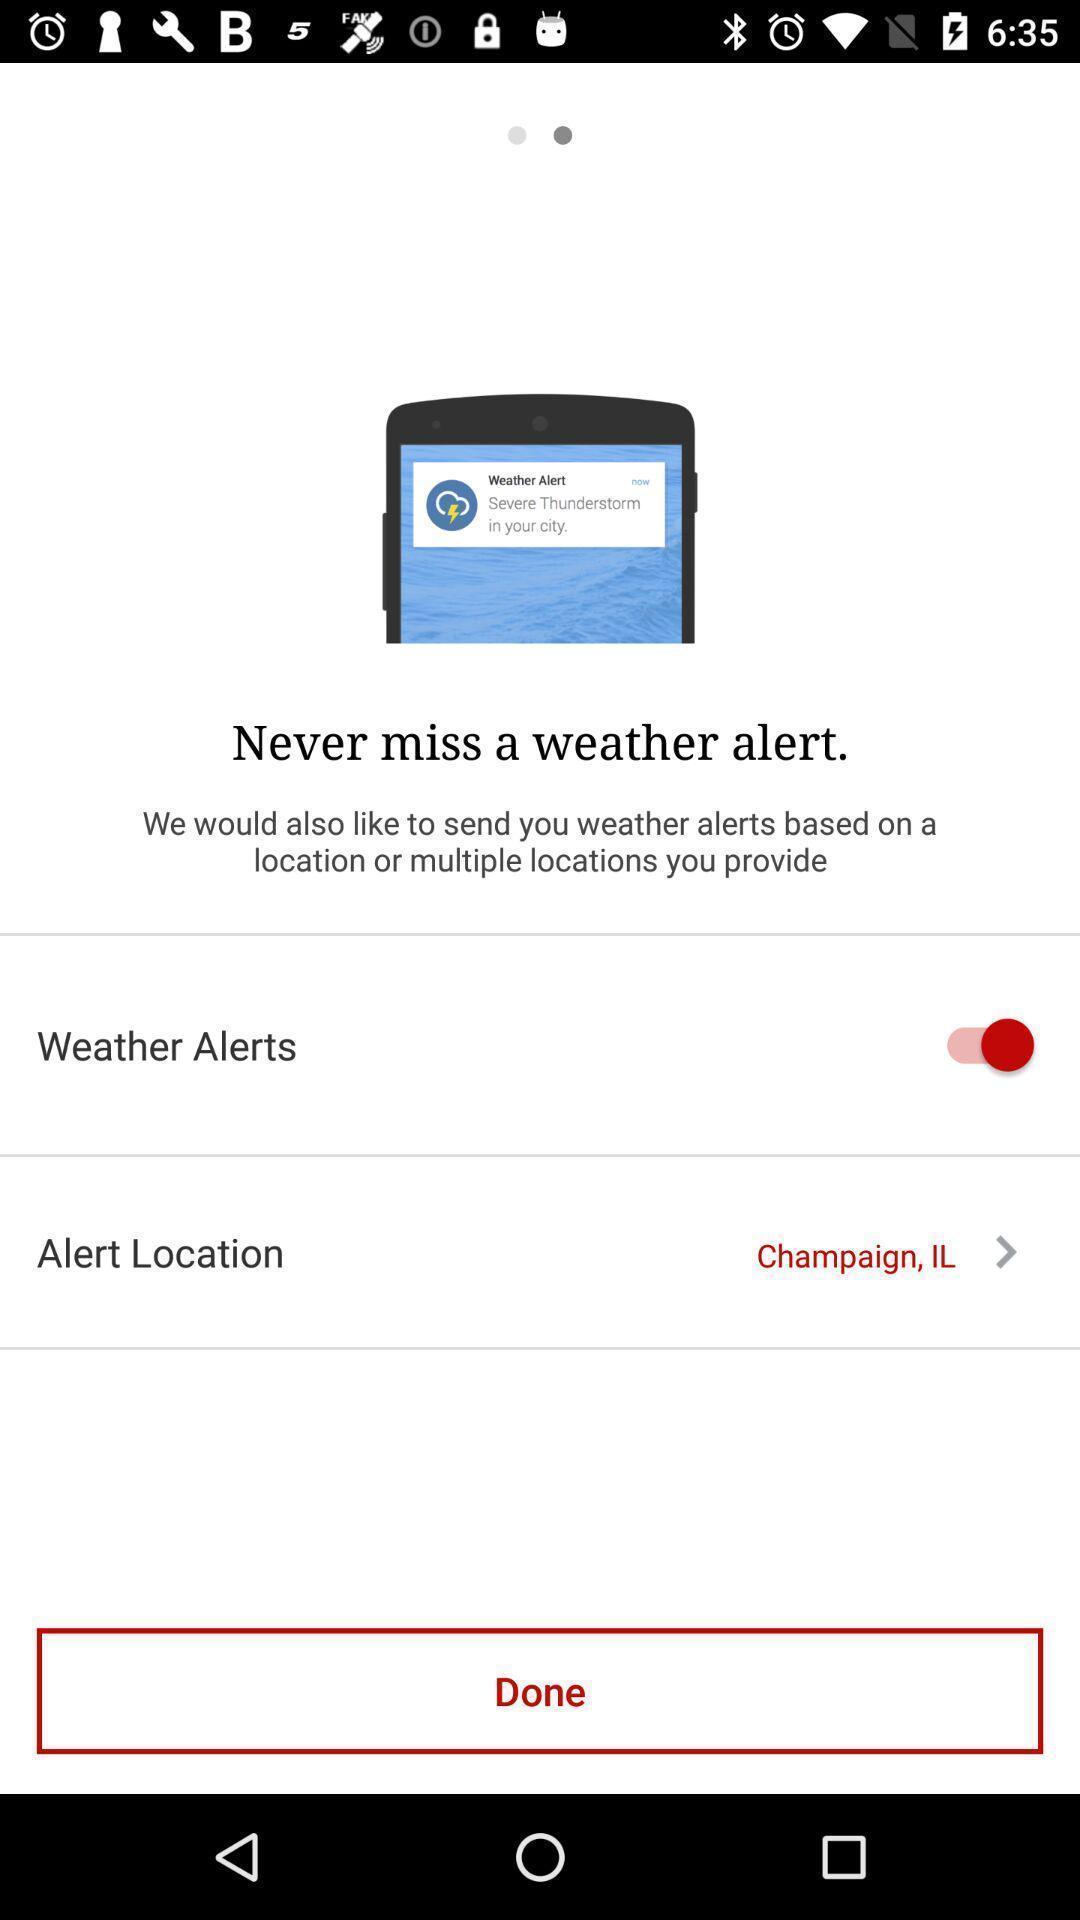Describe this image in words. Screen displaying the option for weather alert. 